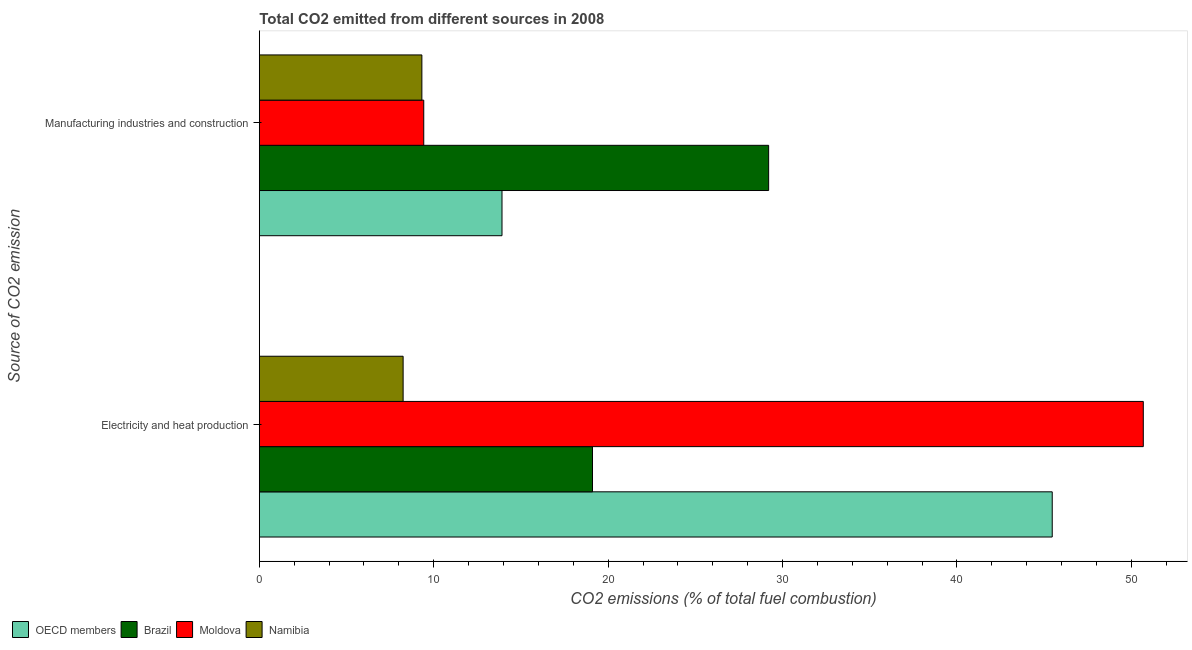Are the number of bars per tick equal to the number of legend labels?
Offer a terse response. Yes. Are the number of bars on each tick of the Y-axis equal?
Provide a short and direct response. Yes. How many bars are there on the 2nd tick from the top?
Your answer should be compact. 4. How many bars are there on the 2nd tick from the bottom?
Keep it short and to the point. 4. What is the label of the 2nd group of bars from the top?
Keep it short and to the point. Electricity and heat production. What is the co2 emissions due to manufacturing industries in Namibia?
Offer a very short reply. 9.32. Across all countries, what is the maximum co2 emissions due to electricity and heat production?
Ensure brevity in your answer.  50.68. Across all countries, what is the minimum co2 emissions due to manufacturing industries?
Keep it short and to the point. 9.32. In which country was the co2 emissions due to manufacturing industries maximum?
Make the answer very short. Brazil. In which country was the co2 emissions due to manufacturing industries minimum?
Your response must be concise. Namibia. What is the total co2 emissions due to manufacturing industries in the graph?
Your answer should be compact. 61.86. What is the difference between the co2 emissions due to manufacturing industries in Moldova and that in Namibia?
Offer a terse response. 0.11. What is the difference between the co2 emissions due to electricity and heat production in OECD members and the co2 emissions due to manufacturing industries in Brazil?
Ensure brevity in your answer.  16.26. What is the average co2 emissions due to manufacturing industries per country?
Your answer should be very brief. 15.47. What is the difference between the co2 emissions due to manufacturing industries and co2 emissions due to electricity and heat production in Namibia?
Provide a succinct answer. 1.08. What is the ratio of the co2 emissions due to electricity and heat production in Brazil to that in Moldova?
Keep it short and to the point. 0.38. How many bars are there?
Your answer should be compact. 8. How many countries are there in the graph?
Your answer should be compact. 4. What is the difference between two consecutive major ticks on the X-axis?
Ensure brevity in your answer.  10. Does the graph contain any zero values?
Offer a very short reply. No. Where does the legend appear in the graph?
Ensure brevity in your answer.  Bottom left. How many legend labels are there?
Offer a terse response. 4. What is the title of the graph?
Keep it short and to the point. Total CO2 emitted from different sources in 2008. Does "Turkmenistan" appear as one of the legend labels in the graph?
Keep it short and to the point. No. What is the label or title of the X-axis?
Provide a short and direct response. CO2 emissions (% of total fuel combustion). What is the label or title of the Y-axis?
Offer a terse response. Source of CO2 emission. What is the CO2 emissions (% of total fuel combustion) of OECD members in Electricity and heat production?
Your response must be concise. 45.46. What is the CO2 emissions (% of total fuel combustion) of Brazil in Electricity and heat production?
Offer a very short reply. 19.1. What is the CO2 emissions (% of total fuel combustion) of Moldova in Electricity and heat production?
Make the answer very short. 50.68. What is the CO2 emissions (% of total fuel combustion) of Namibia in Electricity and heat production?
Offer a terse response. 8.24. What is the CO2 emissions (% of total fuel combustion) of OECD members in Manufacturing industries and construction?
Offer a terse response. 13.91. What is the CO2 emissions (% of total fuel combustion) of Brazil in Manufacturing industries and construction?
Your answer should be very brief. 29.2. What is the CO2 emissions (% of total fuel combustion) in Moldova in Manufacturing industries and construction?
Provide a short and direct response. 9.43. What is the CO2 emissions (% of total fuel combustion) in Namibia in Manufacturing industries and construction?
Make the answer very short. 9.32. Across all Source of CO2 emission, what is the maximum CO2 emissions (% of total fuel combustion) in OECD members?
Provide a short and direct response. 45.46. Across all Source of CO2 emission, what is the maximum CO2 emissions (% of total fuel combustion) in Brazil?
Provide a succinct answer. 29.2. Across all Source of CO2 emission, what is the maximum CO2 emissions (% of total fuel combustion) of Moldova?
Offer a terse response. 50.68. Across all Source of CO2 emission, what is the maximum CO2 emissions (% of total fuel combustion) in Namibia?
Your answer should be very brief. 9.32. Across all Source of CO2 emission, what is the minimum CO2 emissions (% of total fuel combustion) in OECD members?
Your answer should be compact. 13.91. Across all Source of CO2 emission, what is the minimum CO2 emissions (% of total fuel combustion) of Brazil?
Provide a short and direct response. 19.1. Across all Source of CO2 emission, what is the minimum CO2 emissions (% of total fuel combustion) in Moldova?
Your response must be concise. 9.43. Across all Source of CO2 emission, what is the minimum CO2 emissions (% of total fuel combustion) of Namibia?
Ensure brevity in your answer.  8.24. What is the total CO2 emissions (% of total fuel combustion) in OECD members in the graph?
Provide a succinct answer. 59.37. What is the total CO2 emissions (% of total fuel combustion) of Brazil in the graph?
Ensure brevity in your answer.  48.3. What is the total CO2 emissions (% of total fuel combustion) in Moldova in the graph?
Ensure brevity in your answer.  60.11. What is the total CO2 emissions (% of total fuel combustion) of Namibia in the graph?
Provide a succinct answer. 17.56. What is the difference between the CO2 emissions (% of total fuel combustion) in OECD members in Electricity and heat production and that in Manufacturing industries and construction?
Your response must be concise. 31.55. What is the difference between the CO2 emissions (% of total fuel combustion) in Brazil in Electricity and heat production and that in Manufacturing industries and construction?
Offer a terse response. -10.1. What is the difference between the CO2 emissions (% of total fuel combustion) of Moldova in Electricity and heat production and that in Manufacturing industries and construction?
Offer a terse response. 41.26. What is the difference between the CO2 emissions (% of total fuel combustion) of Namibia in Electricity and heat production and that in Manufacturing industries and construction?
Offer a very short reply. -1.08. What is the difference between the CO2 emissions (% of total fuel combustion) of OECD members in Electricity and heat production and the CO2 emissions (% of total fuel combustion) of Brazil in Manufacturing industries and construction?
Give a very brief answer. 16.26. What is the difference between the CO2 emissions (% of total fuel combustion) in OECD members in Electricity and heat production and the CO2 emissions (% of total fuel combustion) in Moldova in Manufacturing industries and construction?
Offer a very short reply. 36.04. What is the difference between the CO2 emissions (% of total fuel combustion) in OECD members in Electricity and heat production and the CO2 emissions (% of total fuel combustion) in Namibia in Manufacturing industries and construction?
Give a very brief answer. 36.14. What is the difference between the CO2 emissions (% of total fuel combustion) of Brazil in Electricity and heat production and the CO2 emissions (% of total fuel combustion) of Moldova in Manufacturing industries and construction?
Ensure brevity in your answer.  9.68. What is the difference between the CO2 emissions (% of total fuel combustion) of Brazil in Electricity and heat production and the CO2 emissions (% of total fuel combustion) of Namibia in Manufacturing industries and construction?
Keep it short and to the point. 9.78. What is the difference between the CO2 emissions (% of total fuel combustion) of Moldova in Electricity and heat production and the CO2 emissions (% of total fuel combustion) of Namibia in Manufacturing industries and construction?
Ensure brevity in your answer.  41.36. What is the average CO2 emissions (% of total fuel combustion) of OECD members per Source of CO2 emission?
Make the answer very short. 29.69. What is the average CO2 emissions (% of total fuel combustion) in Brazil per Source of CO2 emission?
Make the answer very short. 24.15. What is the average CO2 emissions (% of total fuel combustion) in Moldova per Source of CO2 emission?
Keep it short and to the point. 30.05. What is the average CO2 emissions (% of total fuel combustion) of Namibia per Source of CO2 emission?
Your answer should be compact. 8.78. What is the difference between the CO2 emissions (% of total fuel combustion) in OECD members and CO2 emissions (% of total fuel combustion) in Brazil in Electricity and heat production?
Provide a short and direct response. 26.36. What is the difference between the CO2 emissions (% of total fuel combustion) in OECD members and CO2 emissions (% of total fuel combustion) in Moldova in Electricity and heat production?
Keep it short and to the point. -5.22. What is the difference between the CO2 emissions (% of total fuel combustion) in OECD members and CO2 emissions (% of total fuel combustion) in Namibia in Electricity and heat production?
Offer a very short reply. 37.22. What is the difference between the CO2 emissions (% of total fuel combustion) in Brazil and CO2 emissions (% of total fuel combustion) in Moldova in Electricity and heat production?
Provide a short and direct response. -31.58. What is the difference between the CO2 emissions (% of total fuel combustion) in Brazil and CO2 emissions (% of total fuel combustion) in Namibia in Electricity and heat production?
Make the answer very short. 10.86. What is the difference between the CO2 emissions (% of total fuel combustion) in Moldova and CO2 emissions (% of total fuel combustion) in Namibia in Electricity and heat production?
Give a very brief answer. 42.44. What is the difference between the CO2 emissions (% of total fuel combustion) of OECD members and CO2 emissions (% of total fuel combustion) of Brazil in Manufacturing industries and construction?
Provide a short and direct response. -15.29. What is the difference between the CO2 emissions (% of total fuel combustion) of OECD members and CO2 emissions (% of total fuel combustion) of Moldova in Manufacturing industries and construction?
Your answer should be compact. 4.49. What is the difference between the CO2 emissions (% of total fuel combustion) in OECD members and CO2 emissions (% of total fuel combustion) in Namibia in Manufacturing industries and construction?
Offer a terse response. 4.59. What is the difference between the CO2 emissions (% of total fuel combustion) in Brazil and CO2 emissions (% of total fuel combustion) in Moldova in Manufacturing industries and construction?
Your answer should be very brief. 19.78. What is the difference between the CO2 emissions (% of total fuel combustion) of Brazil and CO2 emissions (% of total fuel combustion) of Namibia in Manufacturing industries and construction?
Provide a short and direct response. 19.88. What is the difference between the CO2 emissions (% of total fuel combustion) of Moldova and CO2 emissions (% of total fuel combustion) of Namibia in Manufacturing industries and construction?
Your answer should be compact. 0.11. What is the ratio of the CO2 emissions (% of total fuel combustion) in OECD members in Electricity and heat production to that in Manufacturing industries and construction?
Provide a short and direct response. 3.27. What is the ratio of the CO2 emissions (% of total fuel combustion) in Brazil in Electricity and heat production to that in Manufacturing industries and construction?
Your answer should be compact. 0.65. What is the ratio of the CO2 emissions (% of total fuel combustion) of Moldova in Electricity and heat production to that in Manufacturing industries and construction?
Give a very brief answer. 5.38. What is the ratio of the CO2 emissions (% of total fuel combustion) in Namibia in Electricity and heat production to that in Manufacturing industries and construction?
Your response must be concise. 0.88. What is the difference between the highest and the second highest CO2 emissions (% of total fuel combustion) in OECD members?
Offer a very short reply. 31.55. What is the difference between the highest and the second highest CO2 emissions (% of total fuel combustion) in Brazil?
Offer a very short reply. 10.1. What is the difference between the highest and the second highest CO2 emissions (% of total fuel combustion) of Moldova?
Offer a very short reply. 41.26. What is the difference between the highest and the second highest CO2 emissions (% of total fuel combustion) of Namibia?
Your answer should be very brief. 1.08. What is the difference between the highest and the lowest CO2 emissions (% of total fuel combustion) of OECD members?
Your response must be concise. 31.55. What is the difference between the highest and the lowest CO2 emissions (% of total fuel combustion) in Brazil?
Provide a succinct answer. 10.1. What is the difference between the highest and the lowest CO2 emissions (% of total fuel combustion) in Moldova?
Keep it short and to the point. 41.26. What is the difference between the highest and the lowest CO2 emissions (% of total fuel combustion) of Namibia?
Provide a short and direct response. 1.08. 